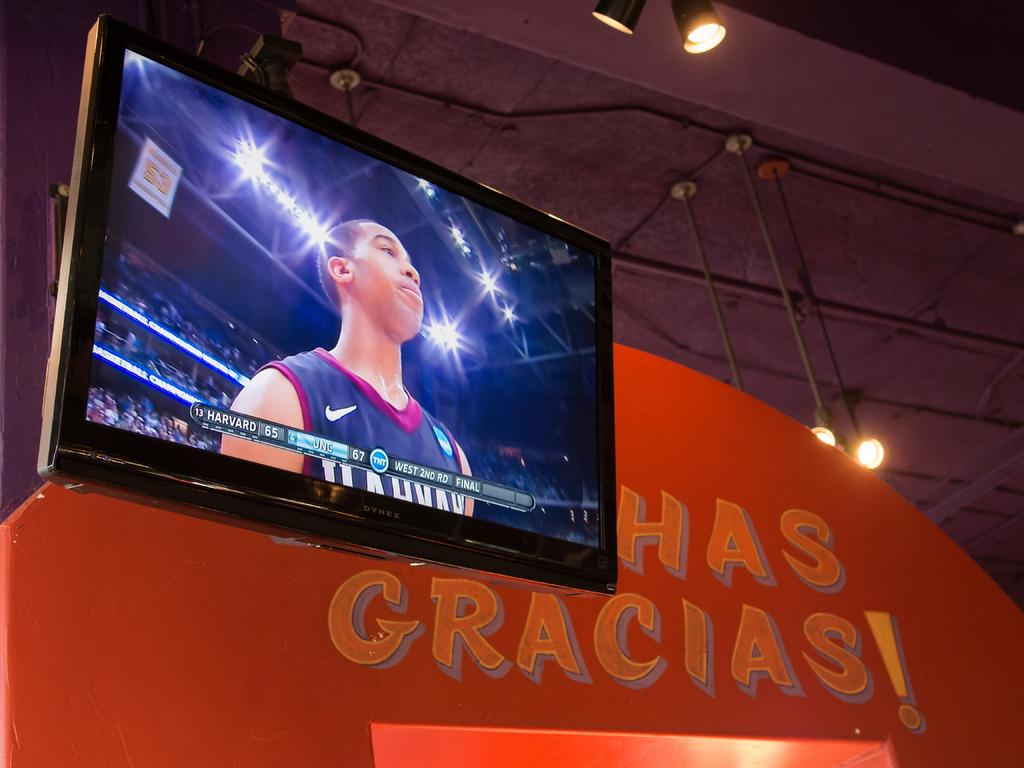Provide a one-sentence caption for the provided image. A TV showing a sports player hands in front of a sign with Muchas Gracias written on it. 